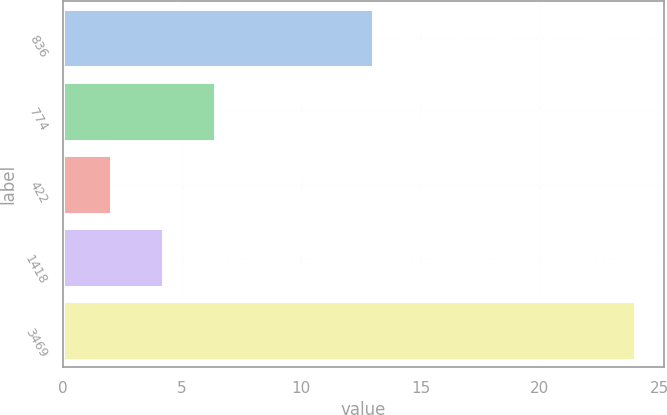Convert chart to OTSL. <chart><loc_0><loc_0><loc_500><loc_500><bar_chart><fcel>836<fcel>774<fcel>422<fcel>1418<fcel>3469<nl><fcel>13<fcel>6.4<fcel>2<fcel>4.2<fcel>24<nl></chart> 